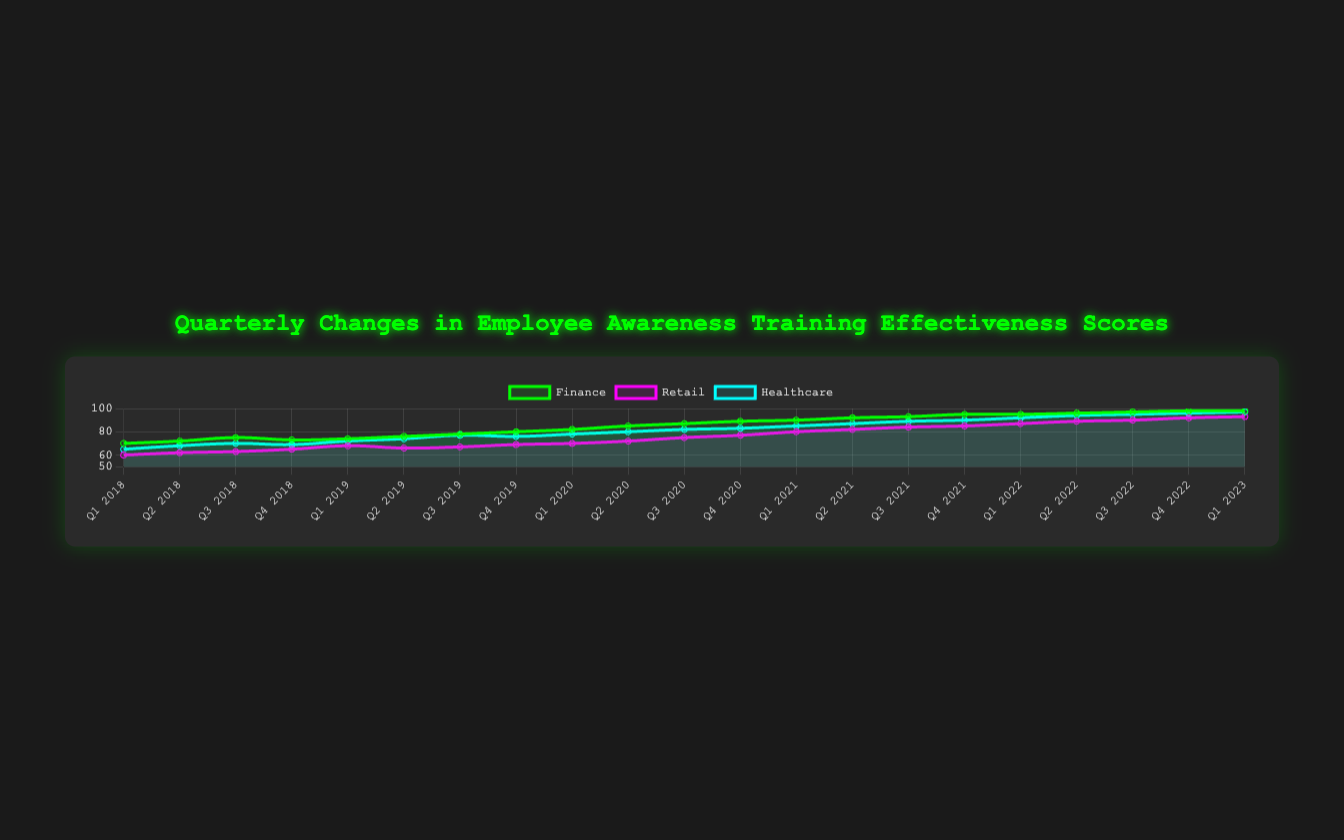What is the overall trend in the effectiveness scores for the Finance industry over the past 5 years? The scores in the Finance industry start at 70 in Q1 2018 and consistently increase each quarter, reaching 98 by Q1 2023. This indicates a steady upward trend in the effectiveness scores over the past 5 years.
Answer: Upward trend Which industry had the highest effectiveness score in Q1 2023? In Q1 2023, Finance and Healthcare both had the highest effectiveness score of 98 and 97 respectively. However, Finance led with 98.
Answer: Finance (98) What is the difference in the effectiveness scores between the Retail and Healthcare industries in Q1 2018? In Q1 2018, the Retail industry had an effectiveness score of 60, and the Healthcare industry had a score of 65. The difference between them is 65 - 60 = 5.
Answer: 5 Which quarter and year did the Finance industry first reach an effectiveness score above 90? To identify when the Finance industry first reached an effectiveness score above 90, we look at the scores over time. The first instance is Q1 2021 with a score of 90.
Answer: Q1 2021 Is the effectiveness score for the Healthcare industry always higher than the Retail industry across all quarters? By comparing the scores across all quarters, it can be observed that Healthcare consistently has higher effectiveness scores than Retail for all corresponding quarters.
Answer: Yes How many quarters did it take for the Retail industry to improve from an effectiveness score of 60 to 80? The effectiveness score for Retail industry was 60 in Q1 2018 and reached 80 by Q1 2021. Counting the quarters from Q1 2018 to Q1 2021 gives us 13 quarters.
Answer: 13 quarters What is the average effectiveness score for the Finance industry in the year 2020? The scores for the Finance industry in 2020 are 82, 85, 87, and 89 for Q1, Q2, Q3, and Q4 respectively. Summing them gives 82 + 85 + 87 + 89 = 343. The average is 343 / 4 = 85.75.
Answer: 85.75 By how much did the effectiveness score for the Healthcare industry increase from Q4 2019 to Q3 2022? The effectiveness score for Healthcare was 76 in Q4 2019 and 95 in Q3 2022. The increase is 95 - 76 = 19.
Answer: 19 Which industry showed the most improvement in their effectiveness scores from Q1 2018 to Q1 2023? The Finance industry improved from 70 to 98 (28 points), the Retail industry improved from 60 to 93 (33 points), and the Healthcare industry improved from 65 to 97 (32 points). Retail showed the most improvement.
Answer: Retail (33 points) What is the visual color representation for the Finance industry line? The line representing the Finance industry is depicted in green color.
Answer: Green 